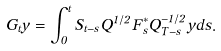Convert formula to latex. <formula><loc_0><loc_0><loc_500><loc_500>G _ { t } y = \int _ { 0 } ^ { t } S _ { t - s } Q ^ { 1 / 2 } F _ { s } ^ { * } Q _ { T - s } ^ { - 1 / 2 } y d s .</formula> 